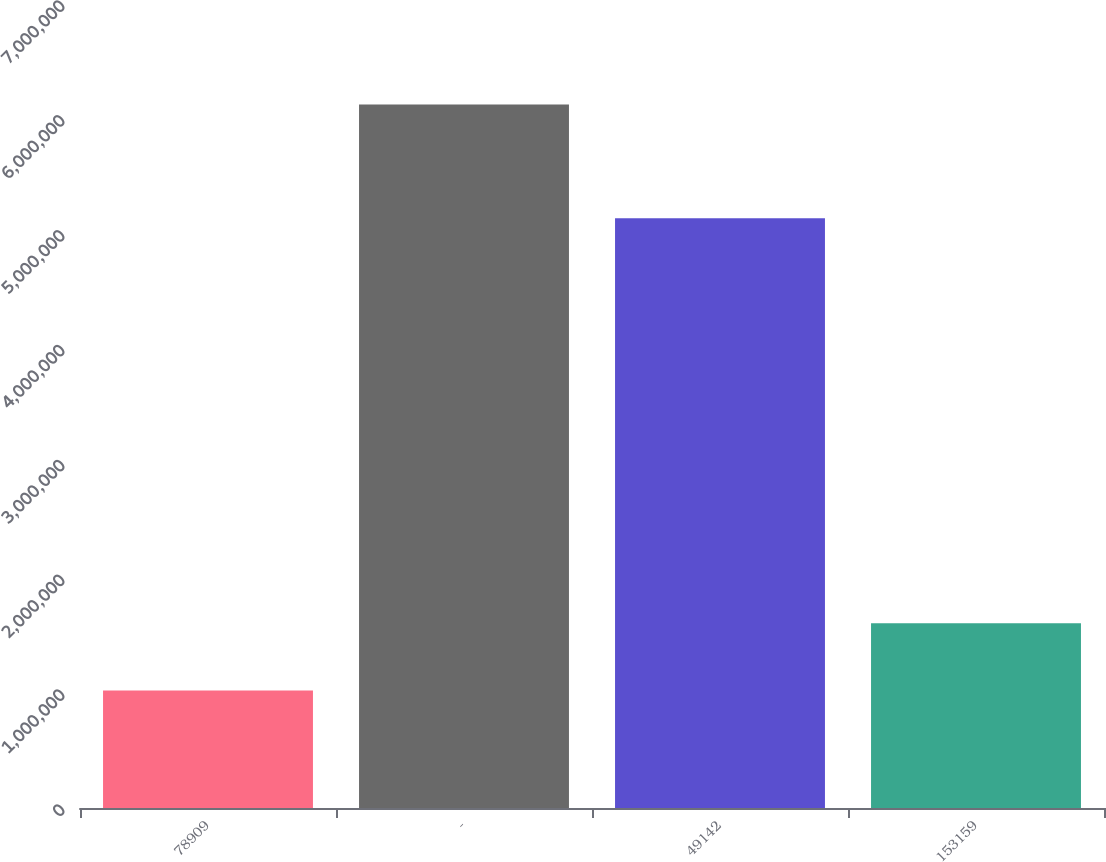Convert chart to OTSL. <chart><loc_0><loc_0><loc_500><loc_500><bar_chart><fcel>78909<fcel>-<fcel>49142<fcel>153159<nl><fcel>1.02234e+06<fcel>6.12572e+06<fcel>5.13422e+06<fcel>1.60911e+06<nl></chart> 